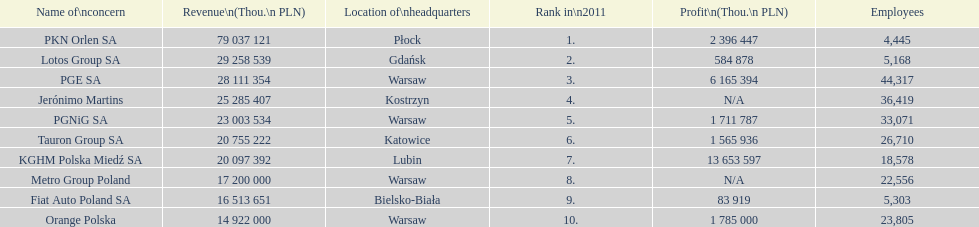What company is the only one with a revenue greater than 75,000,000 thou. pln? PKN Orlen SA. 